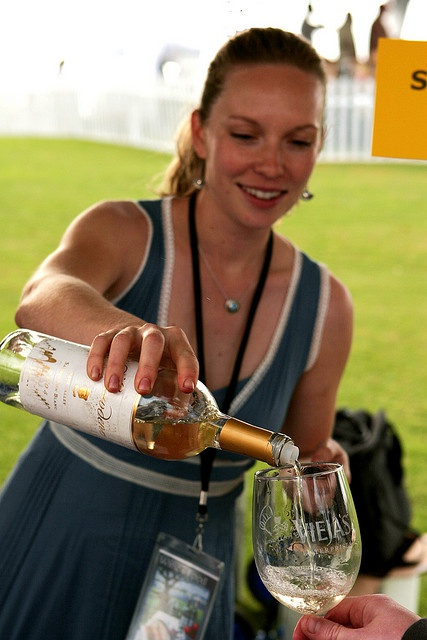Describe the objects in this image and their specific colors. I can see people in white, black, brown, and maroon tones, bottle in white, lightgray, maroon, olive, and darkgray tones, wine glass in white, gray, black, darkgreen, and tan tones, backpack in white, black, darkgreen, gray, and olive tones, and people in white, brown, maroon, and black tones in this image. 